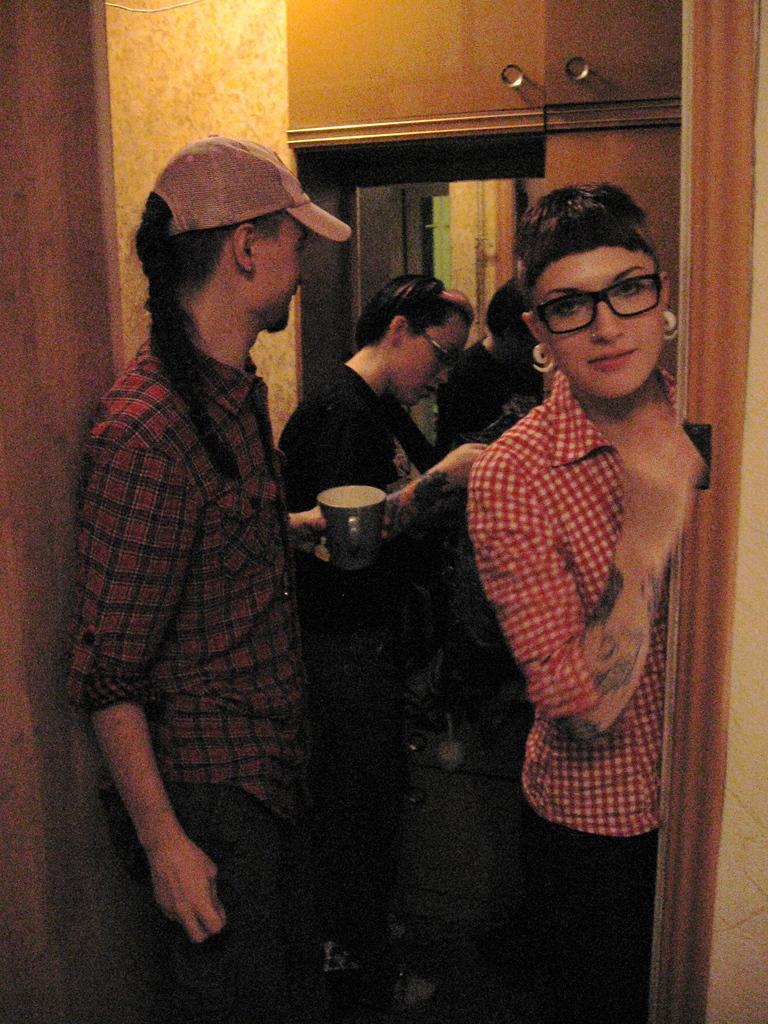Can you describe this image briefly? In this picture we can see three people standing were a woman wore a spectacle and smiling and a person wore a cap and holding a cup, mirror, wall and some objects. 